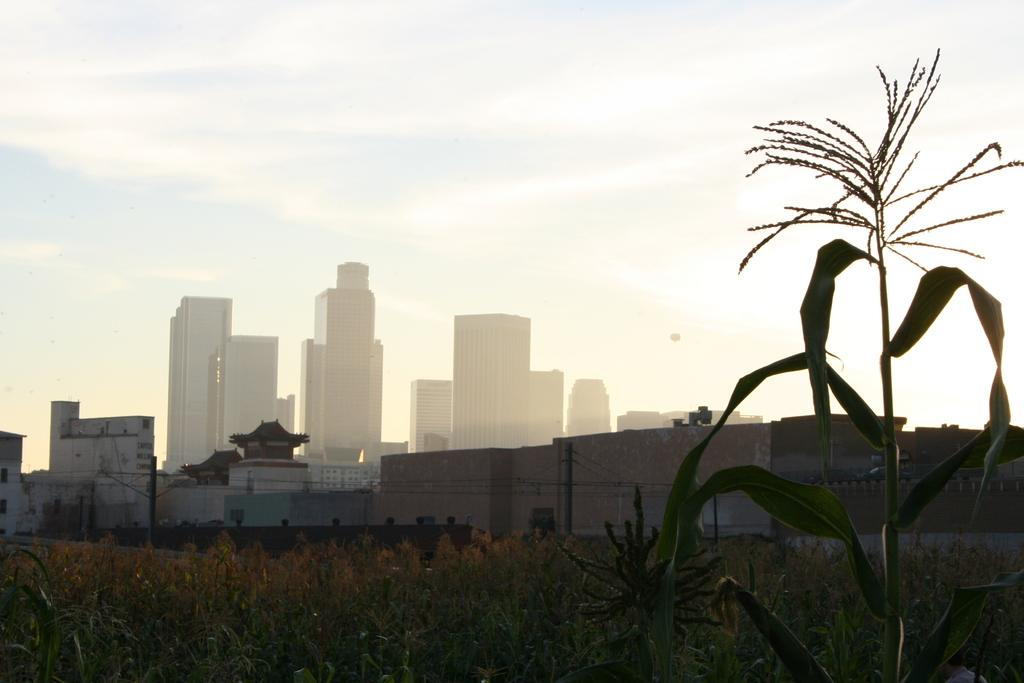What type of vegetation is at the bottom of the image? There are plants at the bottom of the image. What structures are located in the middle of the image? There are buildings in the middle of the image. What can be seen in the sky at the top of the image? There are clouds in the sky at the top of the image. Can you tell me how many toothbrushes are visible in the image? There are no toothbrushes present in the image. What type of window can be seen in the image? There is no window present in the image. 